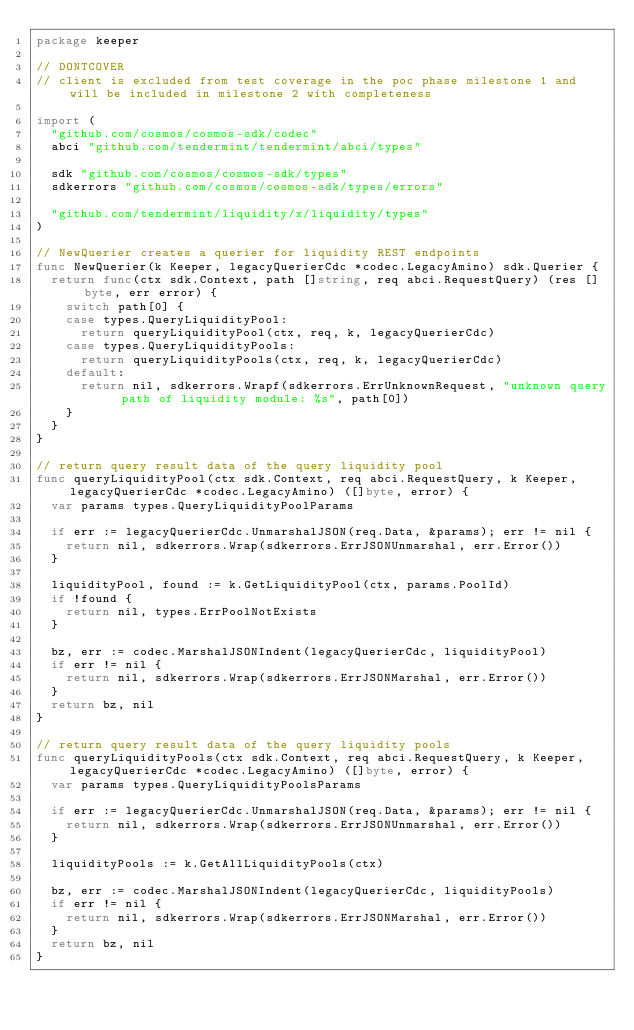Convert code to text. <code><loc_0><loc_0><loc_500><loc_500><_Go_>package keeper

// DONTCOVER
// client is excluded from test coverage in the poc phase milestone 1 and will be included in milestone 2 with completeness

import (
	"github.com/cosmos/cosmos-sdk/codec"
	abci "github.com/tendermint/tendermint/abci/types"

	sdk "github.com/cosmos/cosmos-sdk/types"
	sdkerrors "github.com/cosmos/cosmos-sdk/types/errors"

	"github.com/tendermint/liquidity/x/liquidity/types"
)

// NewQuerier creates a querier for liquidity REST endpoints
func NewQuerier(k Keeper, legacyQuerierCdc *codec.LegacyAmino) sdk.Querier {
	return func(ctx sdk.Context, path []string, req abci.RequestQuery) (res []byte, err error) {
		switch path[0] {
		case types.QueryLiquidityPool:
			return queryLiquidityPool(ctx, req, k, legacyQuerierCdc)
		case types.QueryLiquidityPools:
			return queryLiquidityPools(ctx, req, k, legacyQuerierCdc)
		default:
			return nil, sdkerrors.Wrapf(sdkerrors.ErrUnknownRequest, "unknown query path of liquidity module: %s", path[0])
		}
	}
}

// return query result data of the query liquidity pool
func queryLiquidityPool(ctx sdk.Context, req abci.RequestQuery, k Keeper, legacyQuerierCdc *codec.LegacyAmino) ([]byte, error) {
	var params types.QueryLiquidityPoolParams

	if err := legacyQuerierCdc.UnmarshalJSON(req.Data, &params); err != nil {
		return nil, sdkerrors.Wrap(sdkerrors.ErrJSONUnmarshal, err.Error())
	}

	liquidityPool, found := k.GetLiquidityPool(ctx, params.PoolId)
	if !found {
		return nil, types.ErrPoolNotExists
	}

	bz, err := codec.MarshalJSONIndent(legacyQuerierCdc, liquidityPool)
	if err != nil {
		return nil, sdkerrors.Wrap(sdkerrors.ErrJSONMarshal, err.Error())
	}
	return bz, nil
}

// return query result data of the query liquidity pools
func queryLiquidityPools(ctx sdk.Context, req abci.RequestQuery, k Keeper, legacyQuerierCdc *codec.LegacyAmino) ([]byte, error) {
	var params types.QueryLiquidityPoolsParams

	if err := legacyQuerierCdc.UnmarshalJSON(req.Data, &params); err != nil {
		return nil, sdkerrors.Wrap(sdkerrors.ErrJSONUnmarshal, err.Error())
	}

	liquidityPools := k.GetAllLiquidityPools(ctx)

	bz, err := codec.MarshalJSONIndent(legacyQuerierCdc, liquidityPools)
	if err != nil {
		return nil, sdkerrors.Wrap(sdkerrors.ErrJSONMarshal, err.Error())
	}
	return bz, nil
}
</code> 